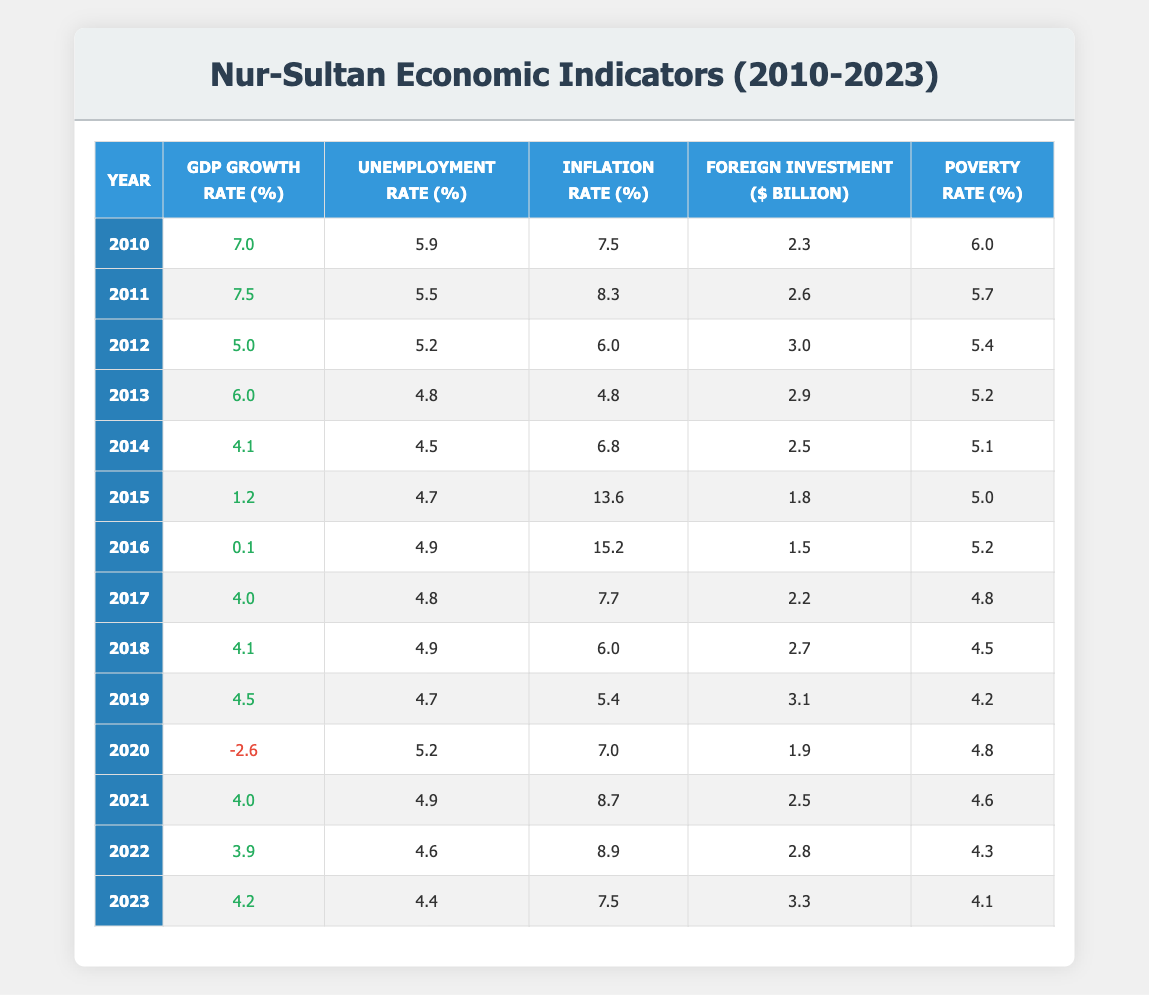What was the highest GDP growth rate in Nur-Sultan between 2010 and 2023? The highest GDP growth rate occurred in 2011, which was 7.5%. By scanning through the GDP Growth Rate column, the value reaches its peak in that year.
Answer: 7.5 In which year did Nur-Sultan experience a negative GDP growth rate? Nur-Sultan experienced a negative GDP growth rate in 2020, when the rate was -2.6%. This is clearly visible in the GDP Growth Rate column, where only the entry for 2020 shows a negative value.
Answer: 2020 What was the average inflation rate from 2010 to 2023? The inflation rates for the years are 7.5, 8.3, 6.0, 4.8, 6.8, 13.6, 15.2, 7.7, 6.0, 5.4, 7.0, 8.7, 8.9, and 7.5. The sum of these values is 7.5 + 8.3 + 6.0 + 4.8 + 6.8 + 13.6 + 15.2 + 7.7 + 6.0 + 5.4 + 7.0 + 8.7 + 8.9 + 7.5 = 111.0 and there are 14 data points, so the average inflation rate is 111.0 / 14 ≈ 7.93.
Answer: Approximately 7.93 Was the unemployment rate in 2013 lower than in 2015? The unemployment rate in 2013 was 4.8% and in 2015 it was 4.7%. Comparing these two values, 4.8 is greater than 4.7, so the statement is false.
Answer: No What was the trend in foreign investment from 2010 to 2023? By observing the Foreign Investment column: it started at 2.3 billion in 2010, had some fluctuations with a notable drop to 1.5 billion in 2016, then generally increased, reaching 3.3 billion in 2023. The trend can be summarized as an overall increase from 2010 to 2023 after some fluctuations, highlighting growth in foreign investment over time.
Answer: Increase with fluctuations What was the change in the poverty rate from 2010 to 2023? In 2010, the poverty rate was 6.0%, and in 2023 it decreased to 4.1%. To find the change, we subtract: 6.0 - 4.1 = 1.9. This indicates a reduction in the poverty rate by 1.9 percentage points over the 13-year period.
Answer: Decreased by 1.9 Which year had the lowest unemployment rate between 2010 and 2023? The lowest unemployment rate occurred in 2014, when it was 4.5%. This can be determined by reviewing the Unemployment Rate column and identifying the minimum value.
Answer: 4.5 How did the inflation rate change from 2015 to 2016? In 2015, the inflation rate was 13.6%, and it dramatically increased to 15.2% in 2016. The change is calculated by subtracting: 15.2 - 13.6 = 1.6, showing an increase of 1.6 percentage points from one year to the next.
Answer: Increased by 1.6 What was the foreign investment in the year with the highest inflation rate? The year with the highest inflation rate was 2016 at 15.2%, and the foreign investment in that same year was 1.5 billion dollars. This involves identifying the row with the highest inflation and checking the corresponding foreign investment value in that row.
Answer: 1.5 billion 